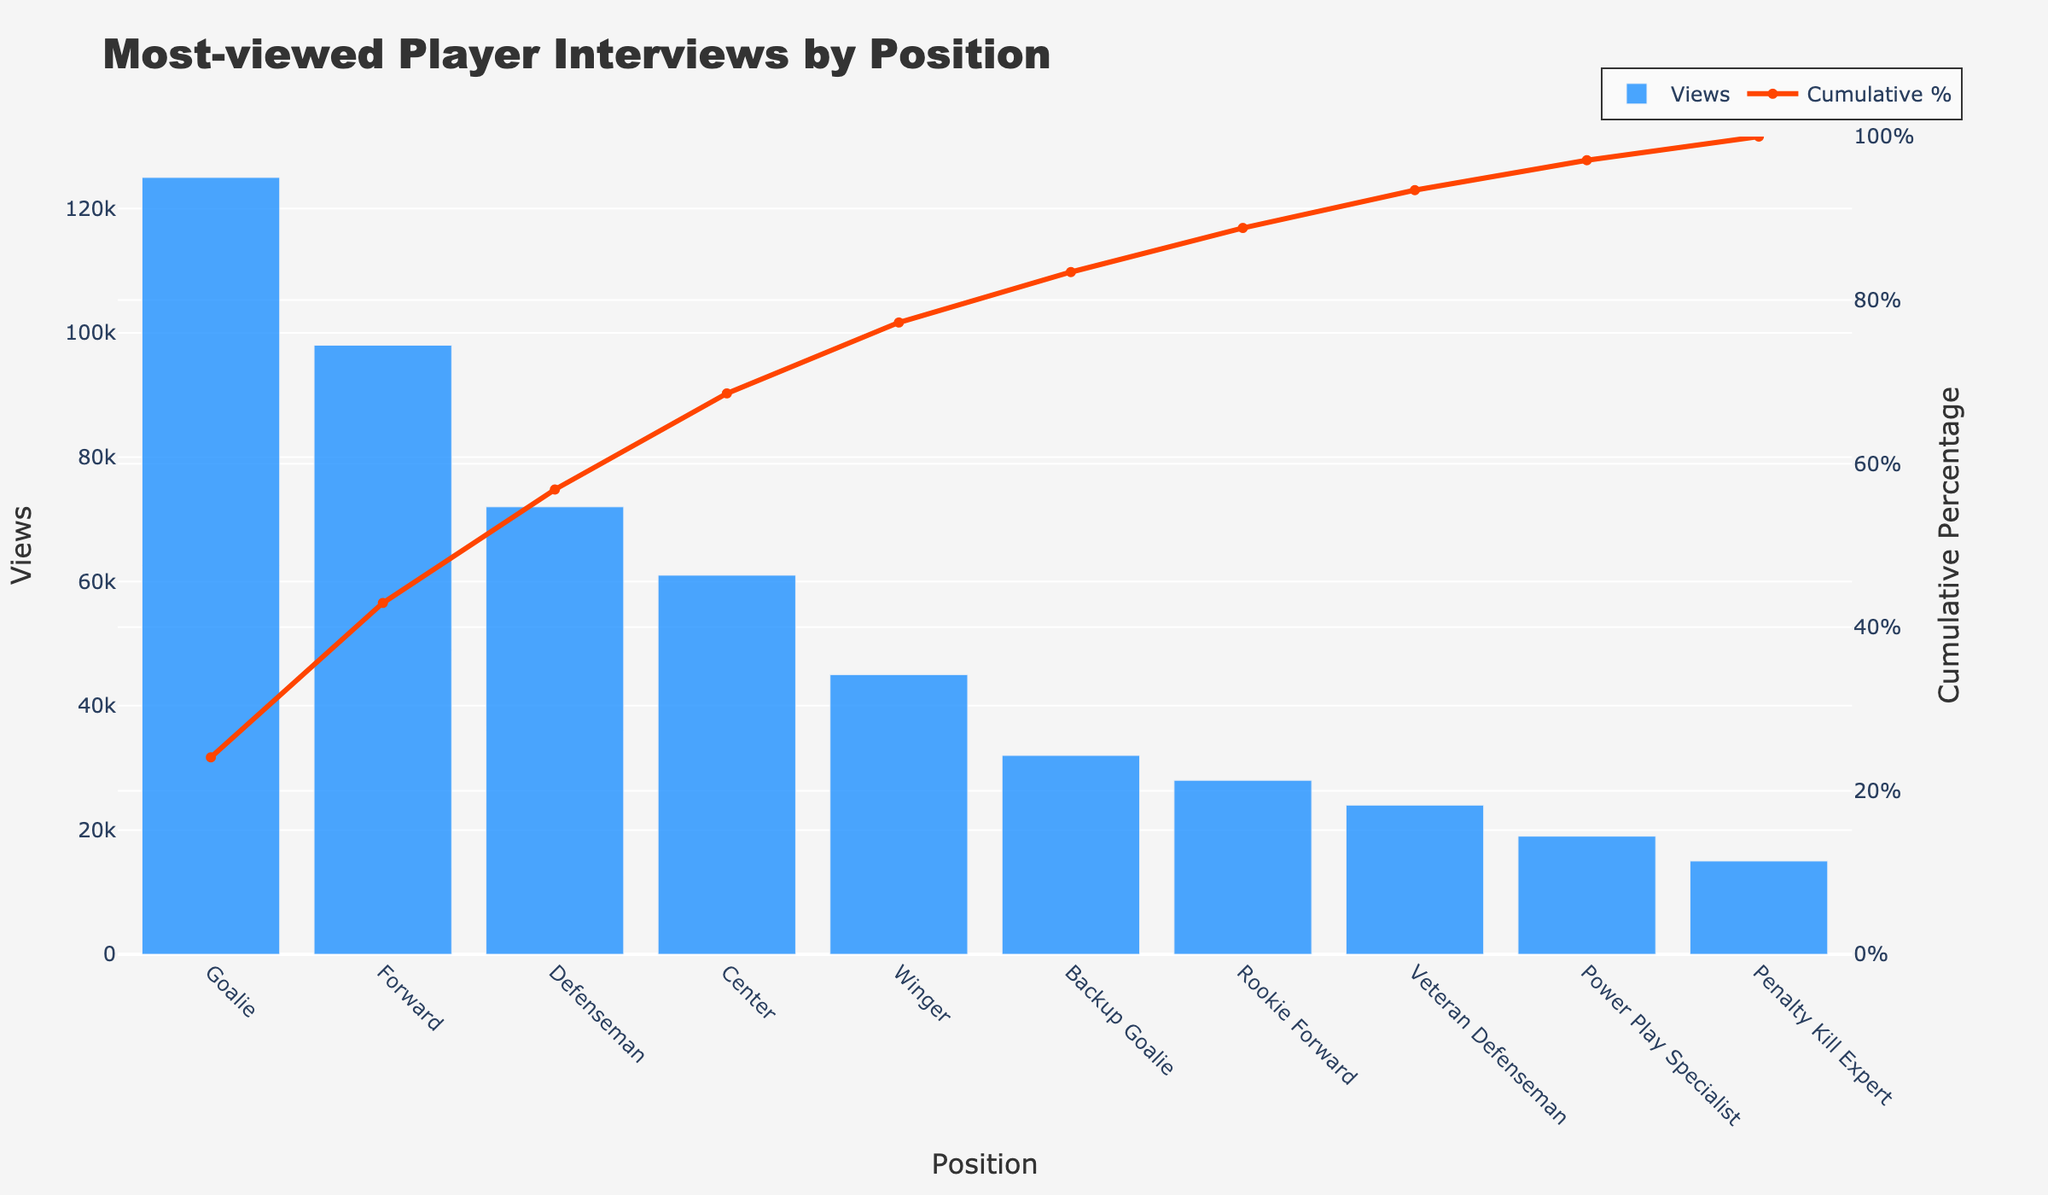What's the title of the figure? The title of the figure is located at the top and is formatted in large, bold text for visibility.
Answer: Most-viewed Player Interviews by Position Which position had the highest number of views? The bar representing the position with the highest views will be the tallest on the chart.
Answer: Goalie What is the cumulative percentage for Forwards? Locate the cumulative percentage line and find the value where it intersects the bar labeled Forward.
Answer: Approximately 38% How many positions are displayed in the chart? Count the number of bars on the x-axis, each representing a different position.
Answer: 10 What are the views for the Defenseman position? Look at the height of the bar for Defenseman on the y-axis to determine the number of views.
Answer: 72,000 Which position has a cumulative percentage closest to 50%? Identify the position where the cumulative percentage line crosses closest to 50% on the y-axis.
Answer: Defenseman How does the total view count compare between Goalies and Backup Goalies? Locate the heights of the bars for both Goalies and Backup Goalies, then subtract the smaller value from the larger one for the comparison.
Answer: 93,000 more views for Goalies What is the cumulative percentage after the top three positions? Sum the cumulative percentages from the first three positions by looking at the cumulative percentage line values for Goalie, Forward, and Defenseman.
Answer: Approximately 73% Which two positions have the smallest difference in views? Compare the heights of the bars to identify the two positions with the closest values.
Answer: Penalty Kill Expert and Power Play Specialist What percentage of the total views does the Center position contribute? Divide the views of the Center by the total views and multiply by 100. The views of the Center is 61,000. The total views are 560,000.
Answer: 10.89% 